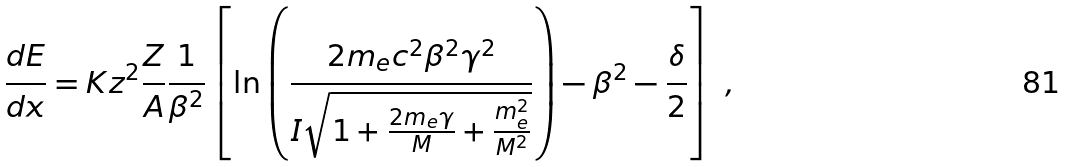<formula> <loc_0><loc_0><loc_500><loc_500>\frac { d E } { d x } = K z ^ { 2 } \frac { Z } { A } \frac { 1 } { \beta ^ { 2 } } \left [ \ln \left ( \frac { 2 m _ { e } c ^ { 2 } \beta ^ { 2 } \gamma ^ { 2 } } { I \sqrt { 1 + \frac { 2 m _ { e } \gamma } { M } + \frac { m _ { e } ^ { 2 } } { M ^ { 2 } } } } \right ) - \beta ^ { 2 } - \frac { \delta } { 2 } \right ] \ ,</formula> 